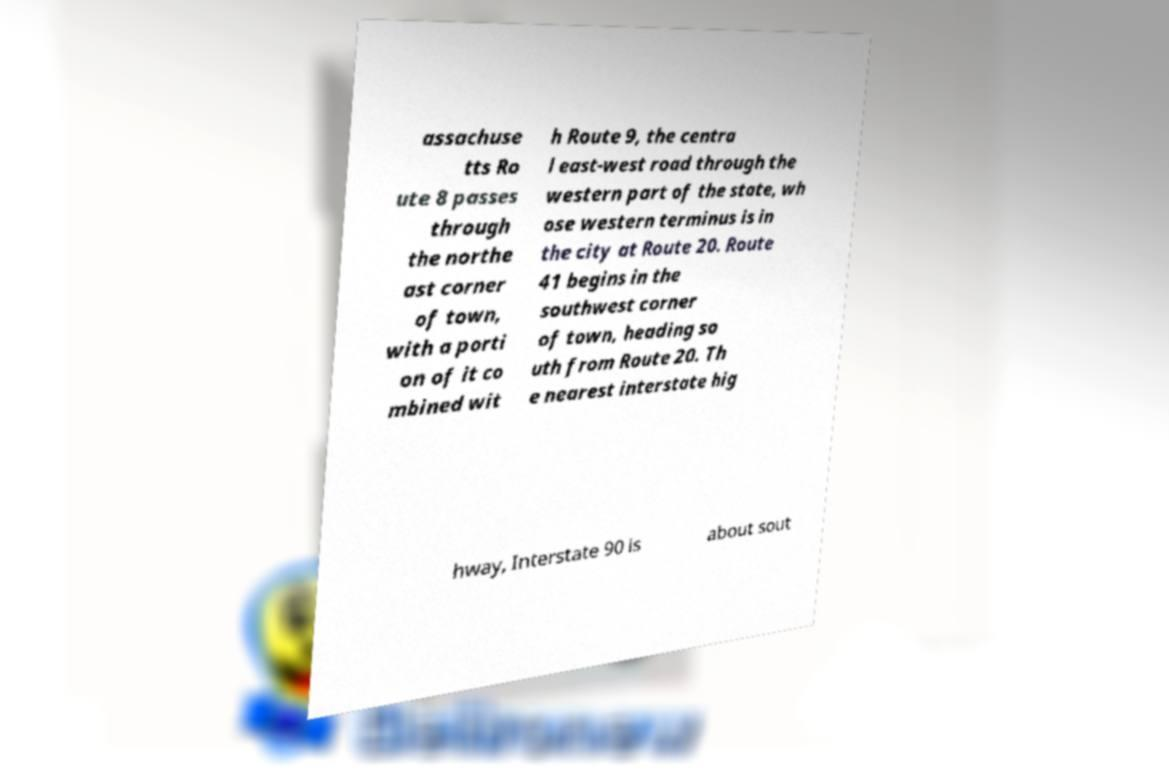Can you read and provide the text displayed in the image?This photo seems to have some interesting text. Can you extract and type it out for me? assachuse tts Ro ute 8 passes through the northe ast corner of town, with a porti on of it co mbined wit h Route 9, the centra l east-west road through the western part of the state, wh ose western terminus is in the city at Route 20. Route 41 begins in the southwest corner of town, heading so uth from Route 20. Th e nearest interstate hig hway, Interstate 90 is about sout 